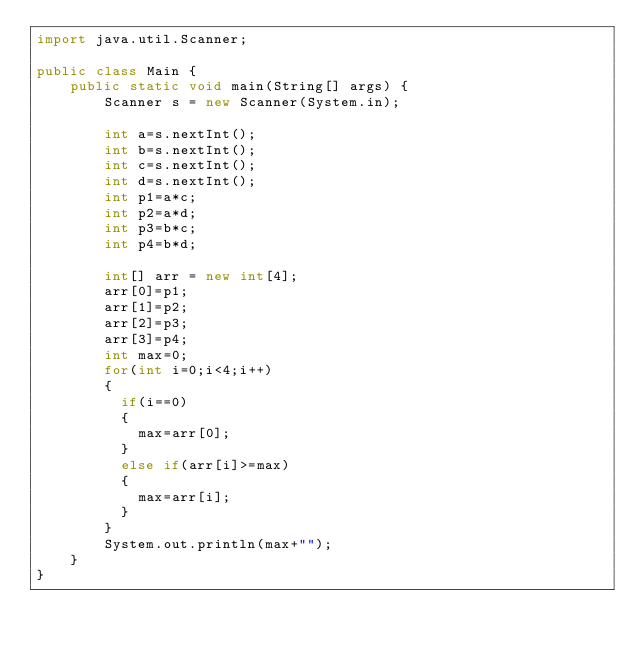<code> <loc_0><loc_0><loc_500><loc_500><_Java_>import java.util.Scanner;

public class Main {
	public static void main(String[] args) {
		Scanner s = new Scanner(System.in);

		int a=s.nextInt();
      	int b=s.nextInt();
      	int c=s.nextInt();
      	int d=s.nextInt();
      	int p1=a*c;
      	int p2=a*d;
      	int p3=b*c;
      	int p4=b*d;

		int[] arr = new int[4];
      	arr[0]=p1;
      	arr[1]=p2;
     	arr[2]=p3;
      	arr[3]=p4;
      	int max=0;
      	for(int i=0;i<4;i++)
        {
          if(i==0)
          {
            max=arr[0];
          }
          else if(arr[i]>=max)
          {
            max=arr[i];
          }
        }
      	System.out.println(max+"");
	}
}
</code> 